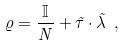Convert formula to latex. <formula><loc_0><loc_0><loc_500><loc_500>\varrho = \frac { \mathbb { I } } { N } + { \vec { \tau } } \cdot { \vec { \lambda } } \ ,</formula> 